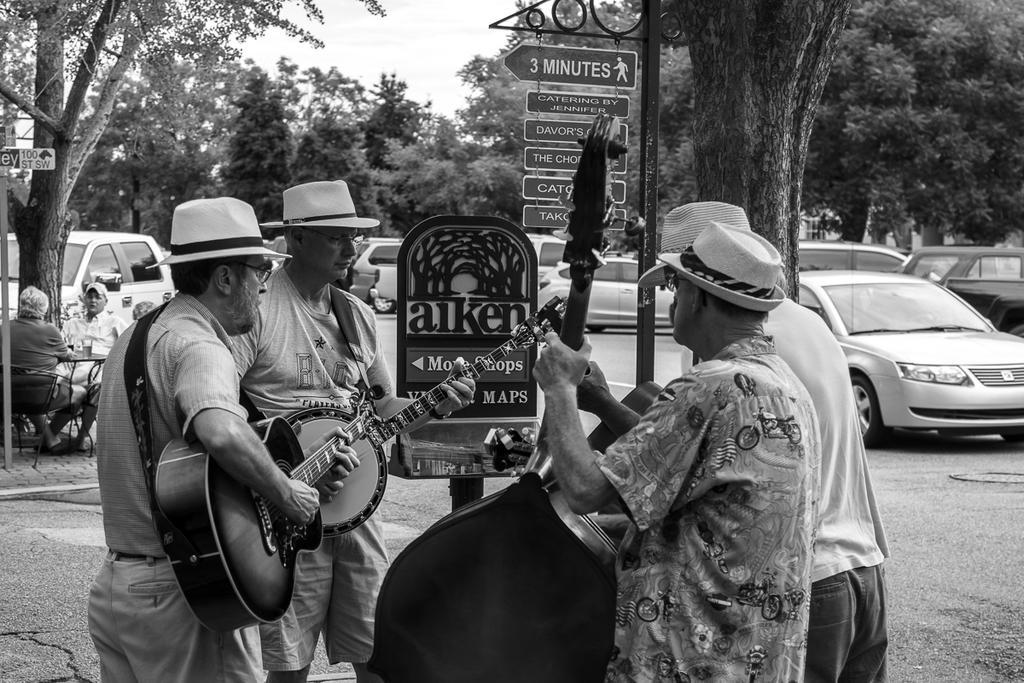Describe this image in one or two sentences. This is a black and white picture. In front of the picture, we see four men are standing and they are holding guitars in their hands. Beside that, we see boards with some text written on it. On the left side, we see people are sitting on the chairs. In front of them, we see a table on which glass is placed. On the right side, there are cars which are parked on the road. There are trees and the cars are parked on the road, in the background. 